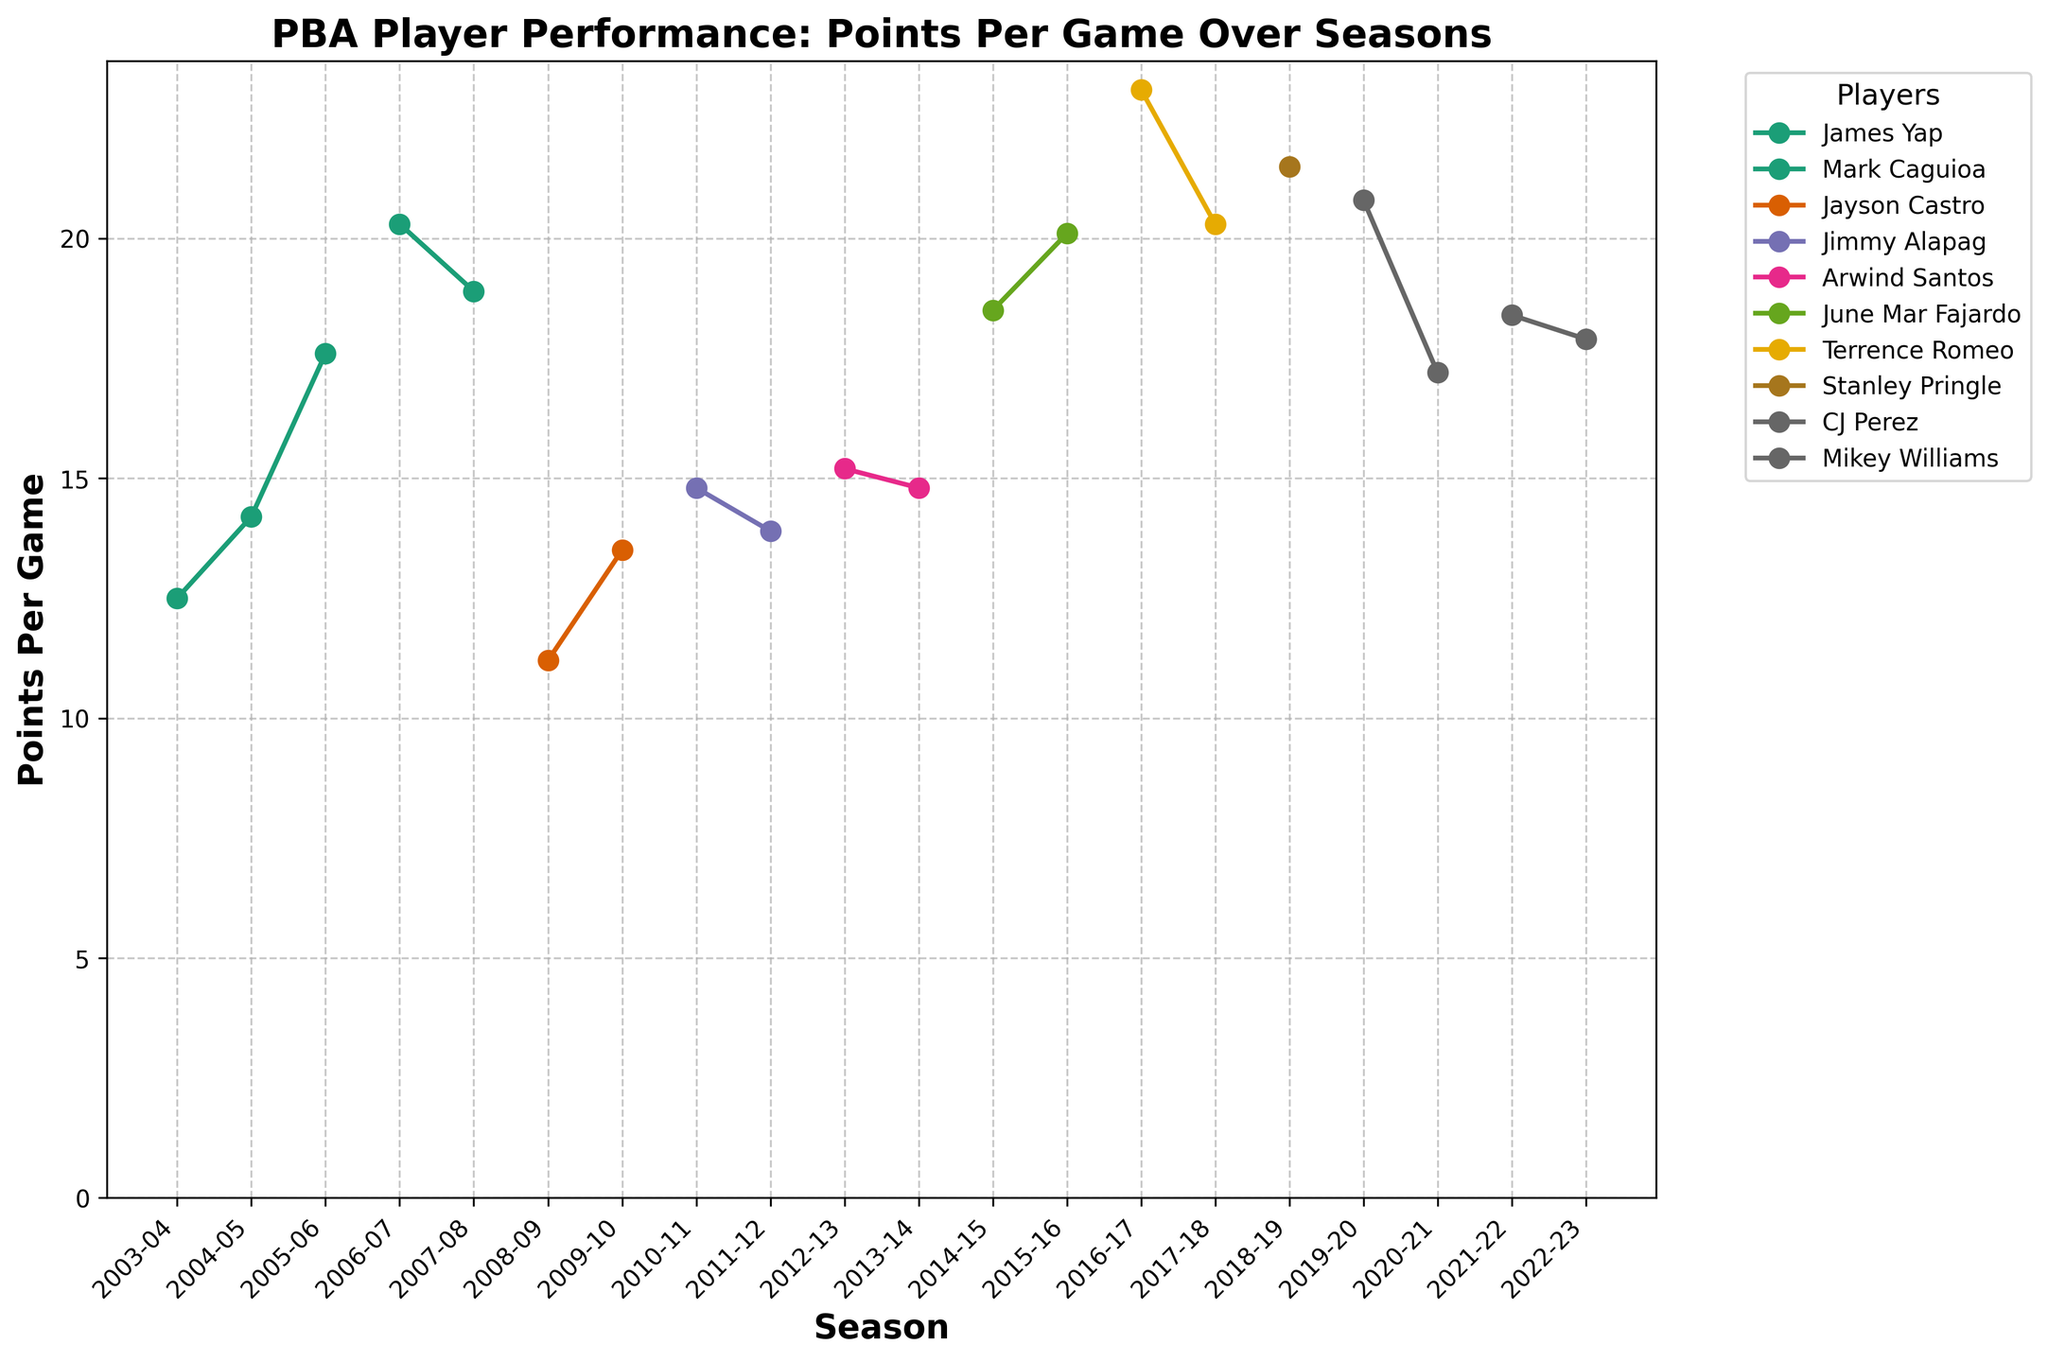What is the highest points per game recorded by any player, and which player achieved it? The highest peak in the chart represents the maximum points per game. Identify the peak and then the corresponding player and season.
Answer: Terrence Romeo (23.1) Which player has the most gradual increase in points per game over consecutive seasons? Observe the line segments with the smallest upward slopes over consecutive seasons. James Yap's line from 2003-2006 increases but not as steeply as others.
Answer: James Yap Compare the points per game for the 2006-07 and 2007-08 seasons for Mark Caguioa. Which season had higher points per game? Compare the heights of the points on the line for Mark Caguioa in 2006-07 and 2007-08. The higher point corresponds to the season with more points per game.
Answer: 2006-07 Who had a higher points-per-game average in the 2019-20 season, CJ Perez or Stanley Pringle? Locate the points for CJ Perez and Stanley Pringle in the 2019-20 season and compare their heights; the higher point indicates a higher points per game.
Answer: CJ Perez What is the average points per game for June Mar Fajardo from 2014 to 2016? Sum the points per game for June Mar Fajardo for the 2014-15 and 2015-16 seasons and then divide by 2: (18.5 + 20.1) / 2.
Answer: 19.3 Which player switched teams after achieving their highest points per game, and in which seasons did this occur? Identify players with lines ending at the highest points before changing color in subsequent seasons. Terrence Romeo's highest points (2016-17) were with GlobalPort; he moved to TNT KaTropa in the next season (2017-18).
Answer: Terrence Romeo (2016-17 to 2017-18) What is the difference in points per game between Mikey Williams in the 2021-22 and 2022-23 seasons? Subtract Mikey Williams' points per game in 2022-23 from his 2021-22 points per game: 18.4 - 17.9.
Answer: 0.5 